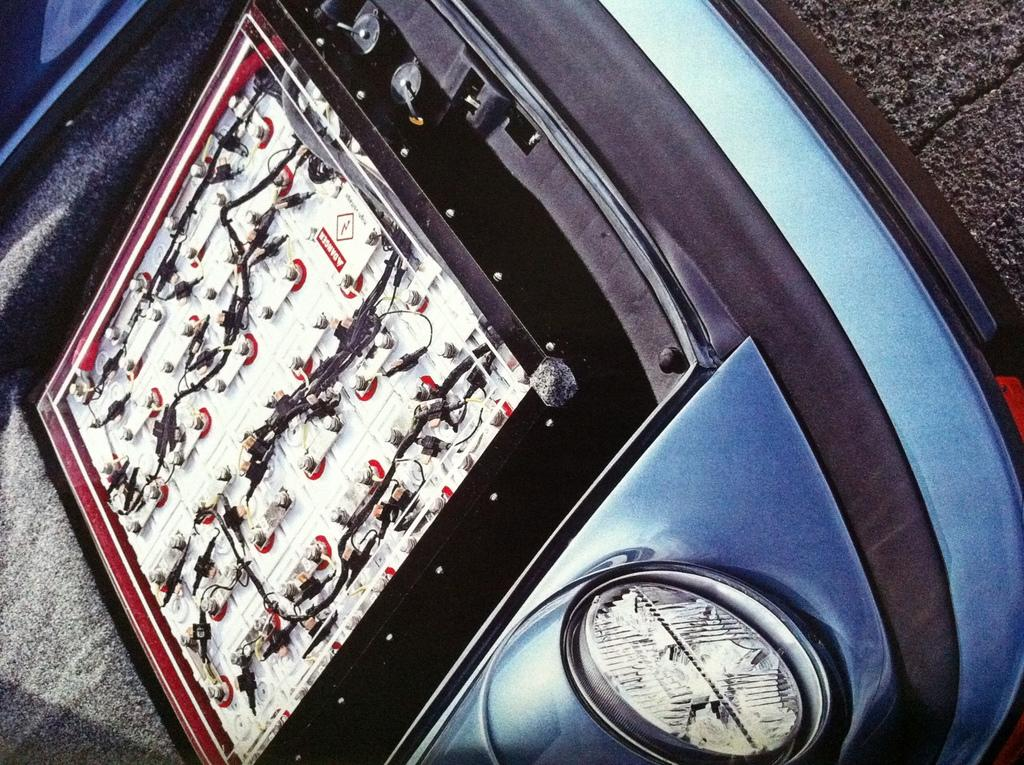What is the main subject of the image? The main subject of the image is the front part of a car. Can you describe any specific features of the car in the image? There is an object fitted on the engine of the car in the image. How does the parent interact with the memory control in the image? There is no parent or memory control present in the image; it only features the front part of a car with an object fitted on the engine. 